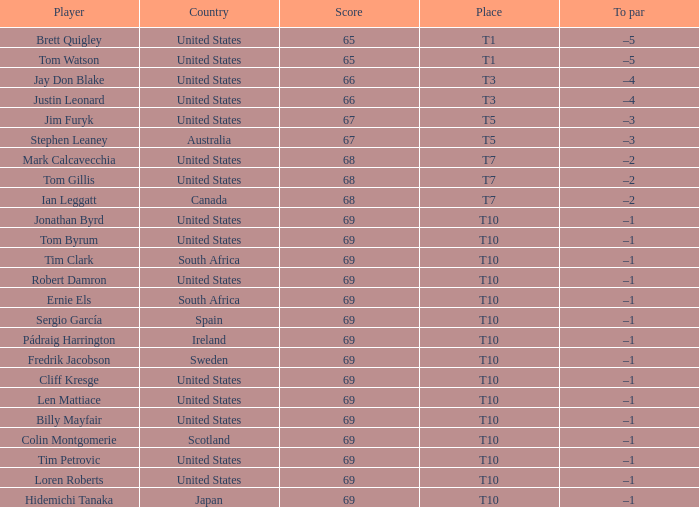Which player is T3? Jay Don Blake, Justin Leonard. 